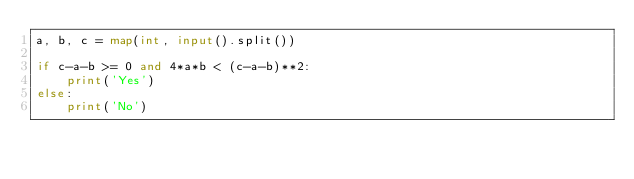<code> <loc_0><loc_0><loc_500><loc_500><_Python_>a, b, c = map(int, input().split())

if c-a-b >= 0 and 4*a*b < (c-a-b)**2:
    print('Yes')
else:
    print('No')</code> 